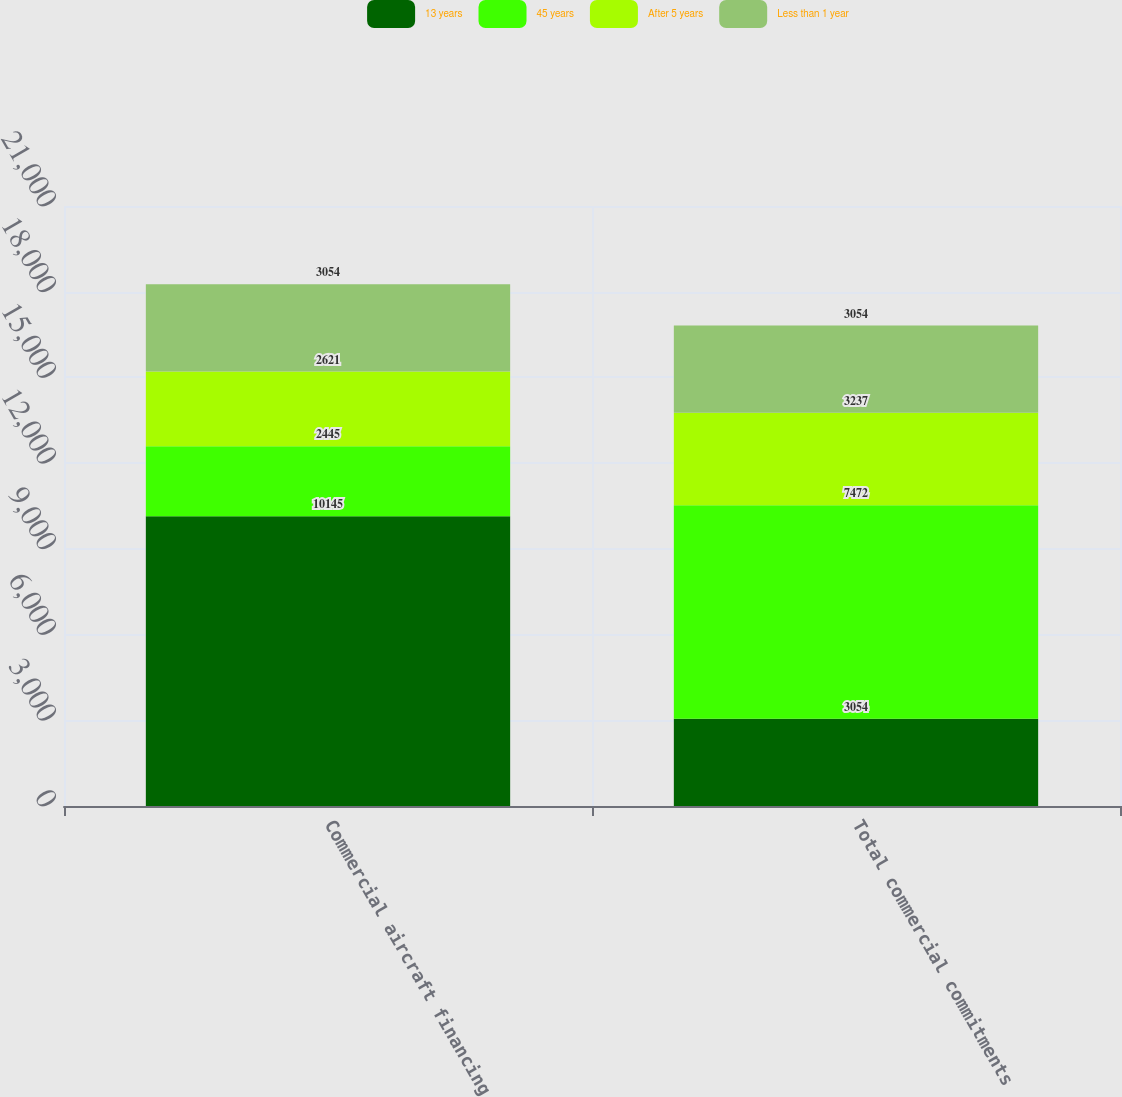<chart> <loc_0><loc_0><loc_500><loc_500><stacked_bar_chart><ecel><fcel>Commercial aircraft financing<fcel>Total commercial commitments<nl><fcel>13 years<fcel>10145<fcel>3054<nl><fcel>45 years<fcel>2445<fcel>7472<nl><fcel>After 5 years<fcel>2621<fcel>3237<nl><fcel>Less than 1 year<fcel>3054<fcel>3054<nl></chart> 